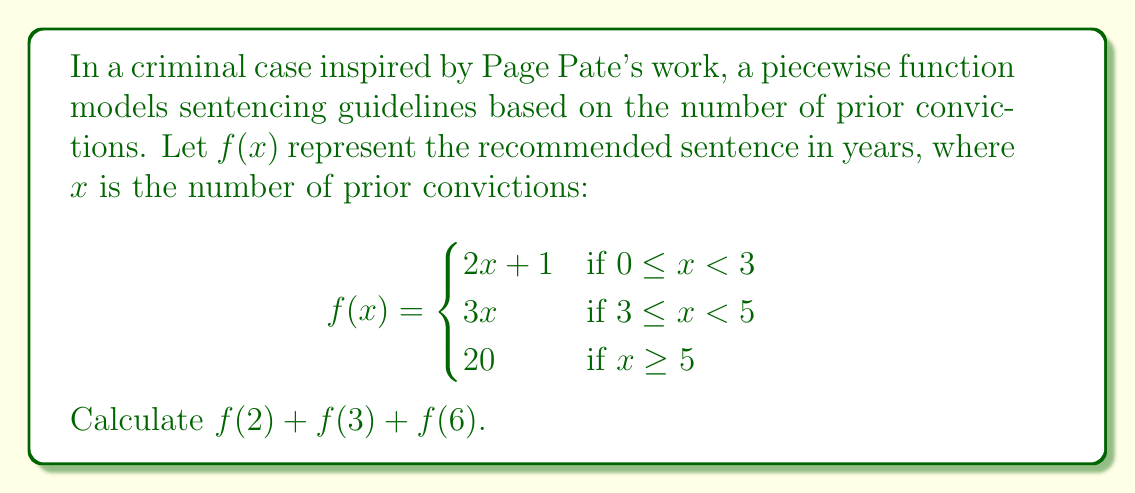Solve this math problem. To solve this problem, we need to evaluate the function $f(x)$ for three different values of $x$: 2, 3, and 6. Let's do this step by step:

1. Evaluate $f(2)$:
   $x = 2$ falls in the range $0 \leq x < 3$, so we use the first piece of the function.
   $f(2) = 2(2) + 1 = 4 + 1 = 5$

2. Evaluate $f(3)$:
   $x = 3$ falls in the range $3 \leq x < 5$, so we use the second piece of the function.
   $f(3) = 3(3) = 9$

3. Evaluate $f(6)$:
   $x = 6$ falls in the range $x \geq 5$, so we use the third piece of the function.
   $f(6) = 20$

4. Sum the results:
   $f(2) + f(3) + f(6) = 5 + 9 + 20 = 34$

Therefore, the sum $f(2) + f(3) + f(6) = 34$.
Answer: $34$ years 